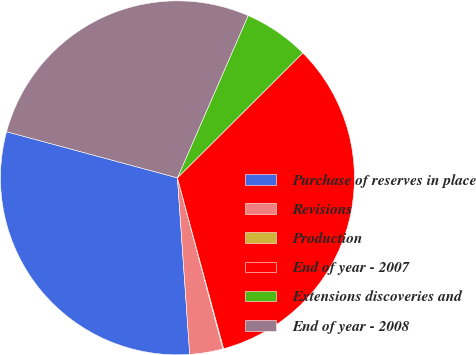<chart> <loc_0><loc_0><loc_500><loc_500><pie_chart><fcel>Purchase of reserves in place<fcel>Revisions<fcel>Production<fcel>End of year - 2007<fcel>Extensions discoveries and<fcel>End of year - 2008<nl><fcel>30.3%<fcel>3.03%<fcel>0.07%<fcel>33.26%<fcel>5.99%<fcel>27.34%<nl></chart> 